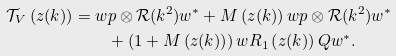Convert formula to latex. <formula><loc_0><loc_0><loc_500><loc_500>\mathcal { T } _ { V } \left ( z ( k ) \right ) = w & p \otimes \mathcal { R } ( k ^ { 2 } ) w ^ { \ast } + M \left ( z ( k ) \right ) w p \otimes \mathcal { R } ( k ^ { 2 } ) w ^ { \ast } \\ & + \left ( 1 + M \left ( z ( k ) \right ) \right ) w R _ { 1 } \left ( z ( k ) \right ) Q w ^ { \ast } .</formula> 